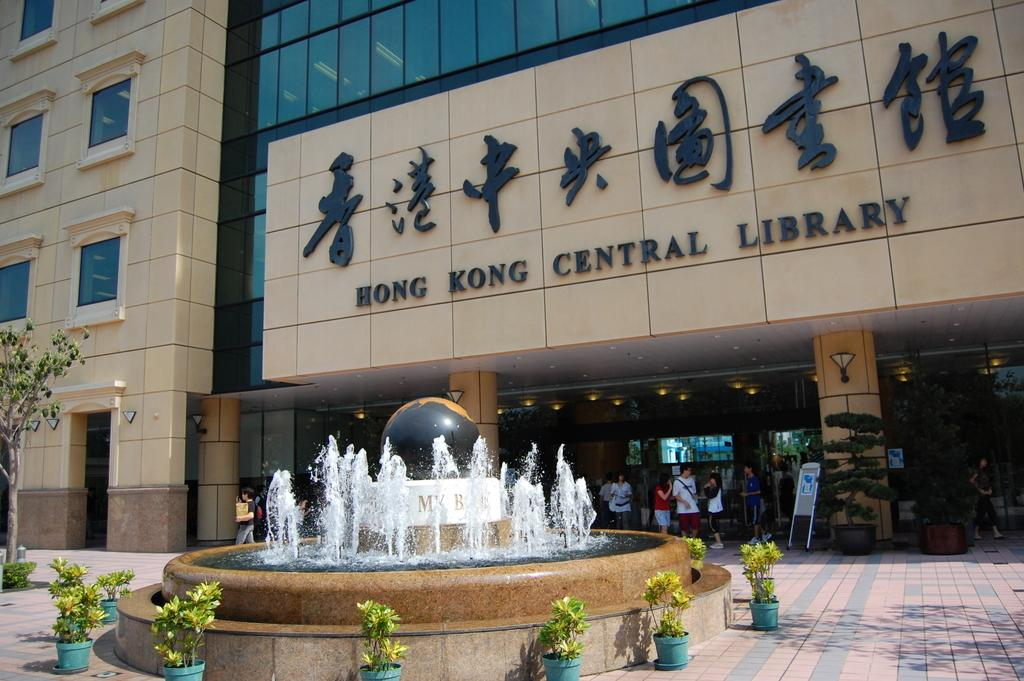<image>
Provide a brief description of the given image. The Hong Kong Central Library has a fountain in front of the entrance 